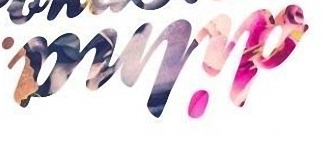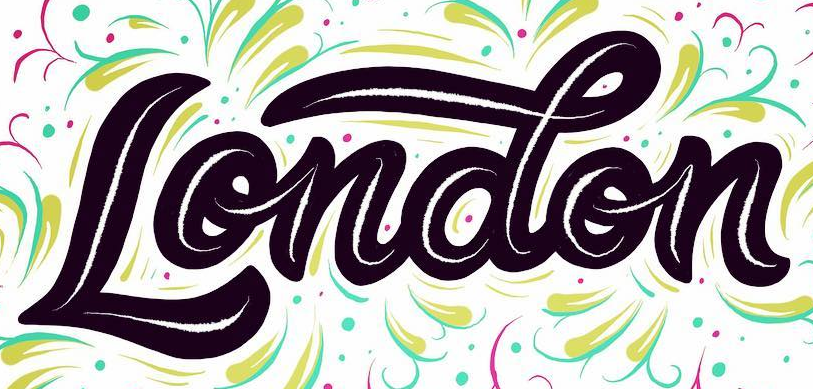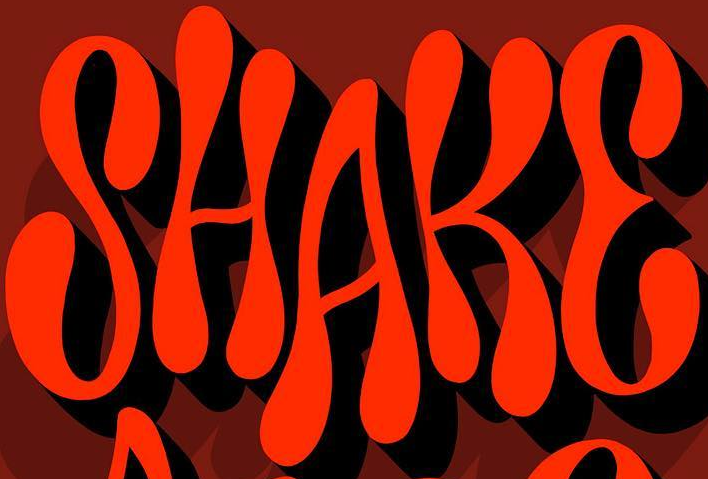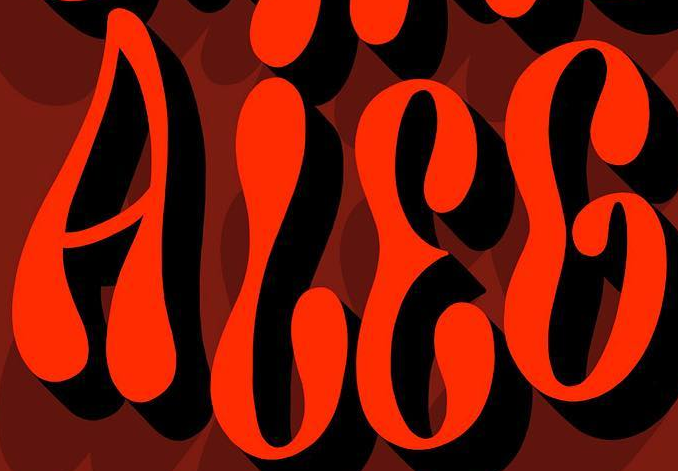Read the text from these images in sequence, separated by a semicolon. dilna; London; SHAKE; ALEG 